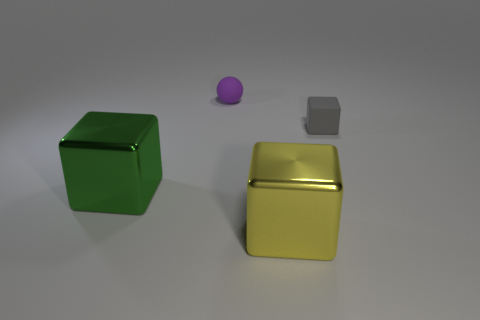Subtract all yellow blocks. How many blocks are left? 2 Subtract all green cubes. How many cubes are left? 2 Add 2 green shiny things. How many objects exist? 6 Subtract all blocks. How many objects are left? 1 Subtract all green cylinders. Subtract all gray cubes. How many objects are left? 3 Add 1 tiny gray blocks. How many tiny gray blocks are left? 2 Add 1 tiny objects. How many tiny objects exist? 3 Subtract 0 purple blocks. How many objects are left? 4 Subtract all green blocks. Subtract all green balls. How many blocks are left? 2 